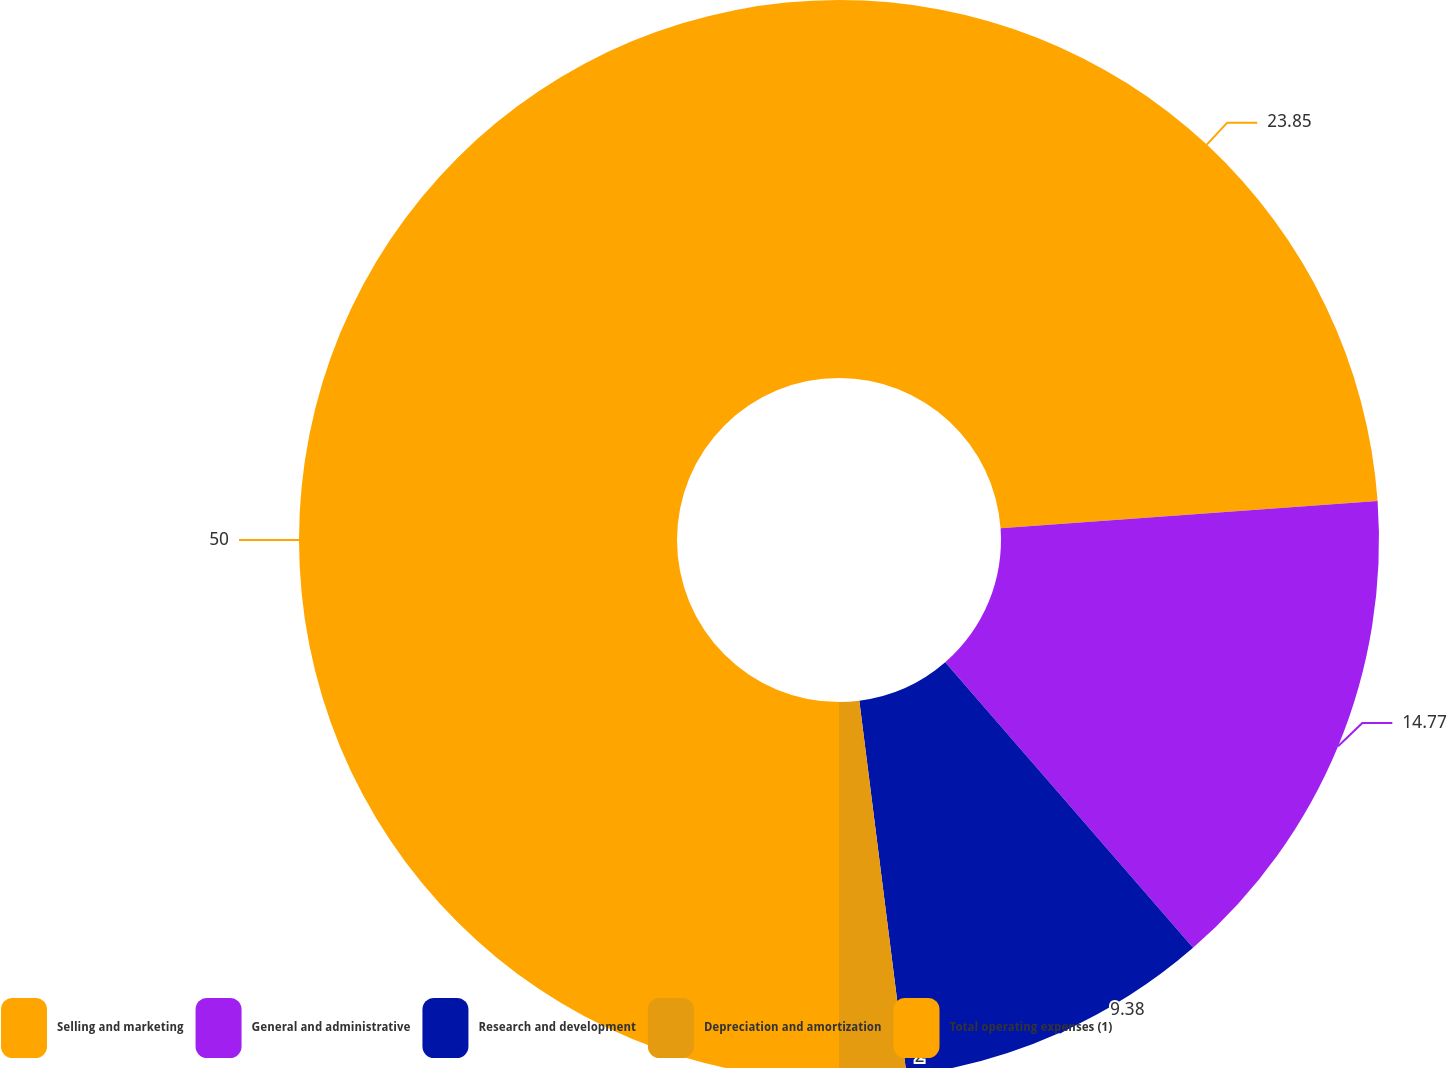Convert chart. <chart><loc_0><loc_0><loc_500><loc_500><pie_chart><fcel>Selling and marketing<fcel>General and administrative<fcel>Research and development<fcel>Depreciation and amortization<fcel>Total operating expenses (1)<nl><fcel>23.85%<fcel>14.77%<fcel>9.38%<fcel>2.0%<fcel>50.0%<nl></chart> 